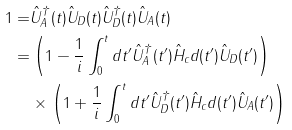Convert formula to latex. <formula><loc_0><loc_0><loc_500><loc_500>1 = & \hat { U } _ { A } ^ { \dag } ( t ) \hat { U } _ { D } ( t ) \hat { U } _ { D } ^ { \dag } ( t ) \hat { U } _ { A } ( t ) \\ = & \left ( 1 - \frac { 1 } { i } \int _ { 0 } ^ { t } d t ^ { \prime } \hat { U } _ { A } ^ { \dag } ( t ^ { \prime } ) \hat { H } _ { c } d ( t ^ { \prime } ) \hat { U } _ { D } ( t ^ { \prime } ) \right ) \\ & \times \left ( 1 + \frac { 1 } { i } \int _ { 0 } ^ { t } d t ^ { \prime } \hat { U } _ { D } ^ { \dag } ( t ^ { \prime } ) \hat { H } _ { c } d ( t ^ { \prime } ) \hat { U } _ { A } ( t ^ { \prime } ) \right )</formula> 